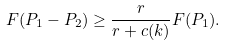<formula> <loc_0><loc_0><loc_500><loc_500>F ( P _ { 1 } - P _ { 2 } ) \geq \frac { r } { r + c ( k ) } F ( P _ { 1 } ) .</formula> 